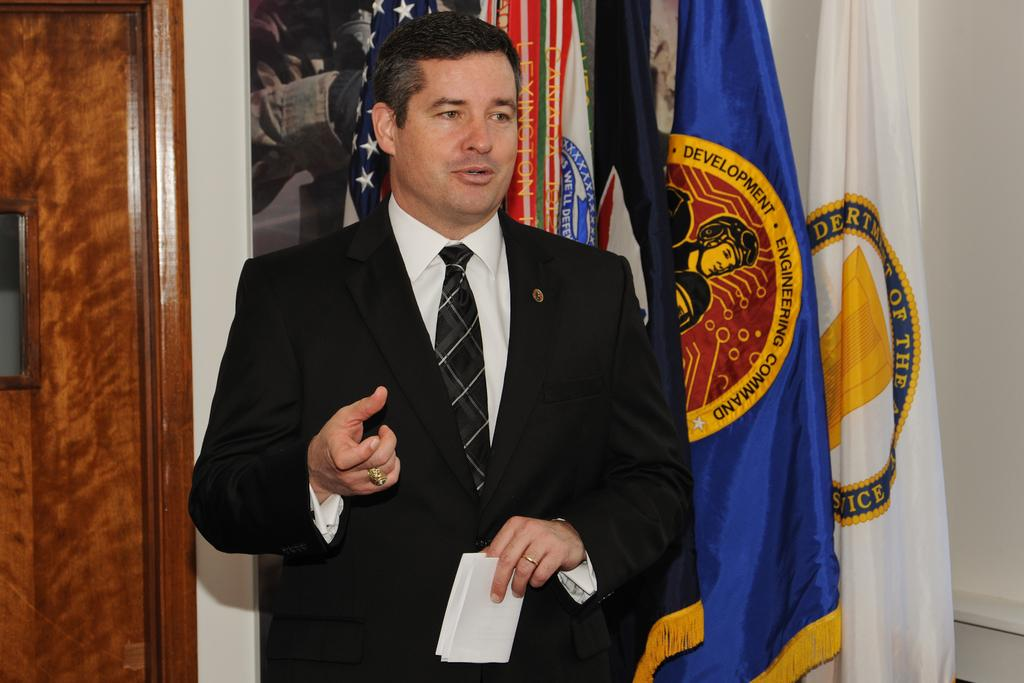<image>
Provide a brief description of the given image. A man stands near a flag with the word development on it. 